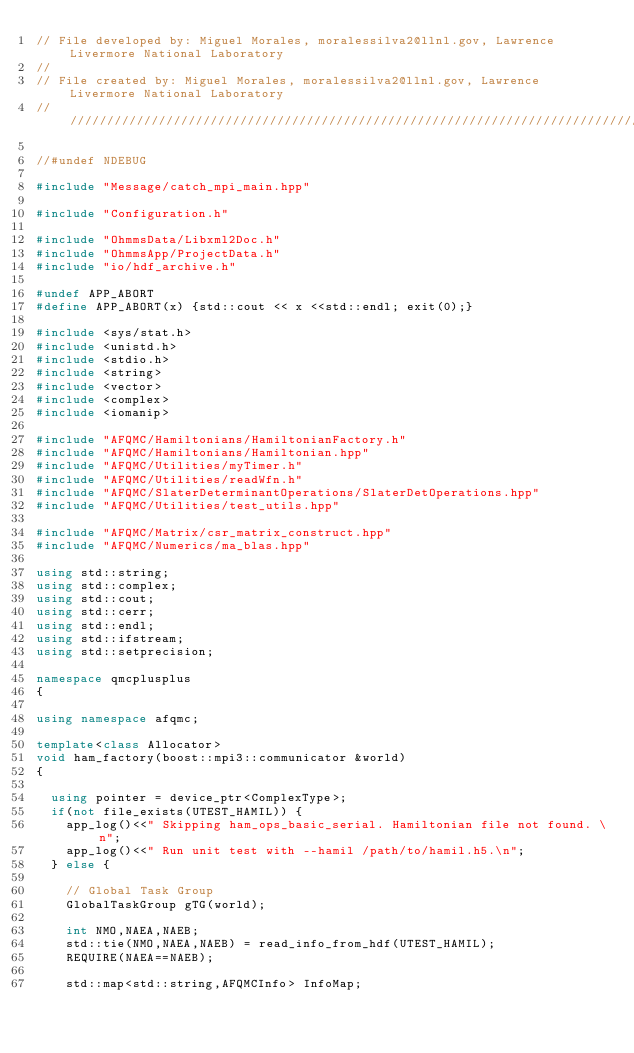Convert code to text. <code><loc_0><loc_0><loc_500><loc_500><_C++_>// File developed by: Miguel Morales, moralessilva2@llnl.gov, Lawrence Livermore National Laboratory
//
// File created by: Miguel Morales, moralessilva2@llnl.gov, Lawrence Livermore National Laboratory
//////////////////////////////////////////////////////////////////////////////////////

//#undef NDEBUG

#include "Message/catch_mpi_main.hpp"

#include "Configuration.h"

#include "OhmmsData/Libxml2Doc.h"
#include "OhmmsApp/ProjectData.h"
#include "io/hdf_archive.h"

#undef APP_ABORT
#define APP_ABORT(x) {std::cout << x <<std::endl; exit(0);}

#include <sys/stat.h>
#include <unistd.h>
#include <stdio.h>
#include <string>
#include <vector>
#include <complex>
#include <iomanip>

#include "AFQMC/Hamiltonians/HamiltonianFactory.h"
#include "AFQMC/Hamiltonians/Hamiltonian.hpp"
#include "AFQMC/Utilities/myTimer.h"
#include "AFQMC/Utilities/readWfn.h"
#include "AFQMC/SlaterDeterminantOperations/SlaterDetOperations.hpp"
#include "AFQMC/Utilities/test_utils.hpp"

#include "AFQMC/Matrix/csr_matrix_construct.hpp"
#include "AFQMC/Numerics/ma_blas.hpp"

using std::string;
using std::complex;
using std::cout;
using std::cerr;
using std::endl;
using std::ifstream;
using std::setprecision;

namespace qmcplusplus
{

using namespace afqmc;

template<class Allocator>
void ham_factory(boost::mpi3::communicator &world)
{

  using pointer = device_ptr<ComplexType>;
  if(not file_exists(UTEST_HAMIL)) {
    app_log()<<" Skipping ham_ops_basic_serial. Hamiltonian file not found. \n";
    app_log()<<" Run unit test with --hamil /path/to/hamil.h5.\n";
  } else {

    // Global Task Group
    GlobalTaskGroup gTG(world);

    int NMO,NAEA,NAEB;
    std::tie(NMO,NAEA,NAEB) = read_info_from_hdf(UTEST_HAMIL);
    REQUIRE(NAEA==NAEB);

    std::map<std::string,AFQMCInfo> InfoMap;</code> 